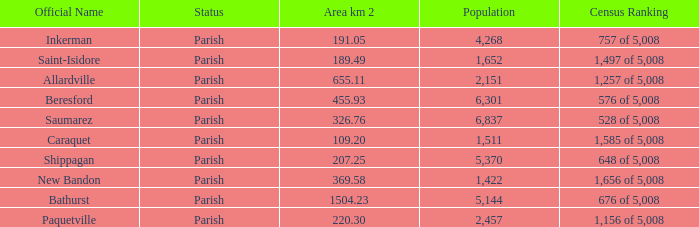What is the Area of the Allardville Parish with a Population smaller than 2,151? None. 